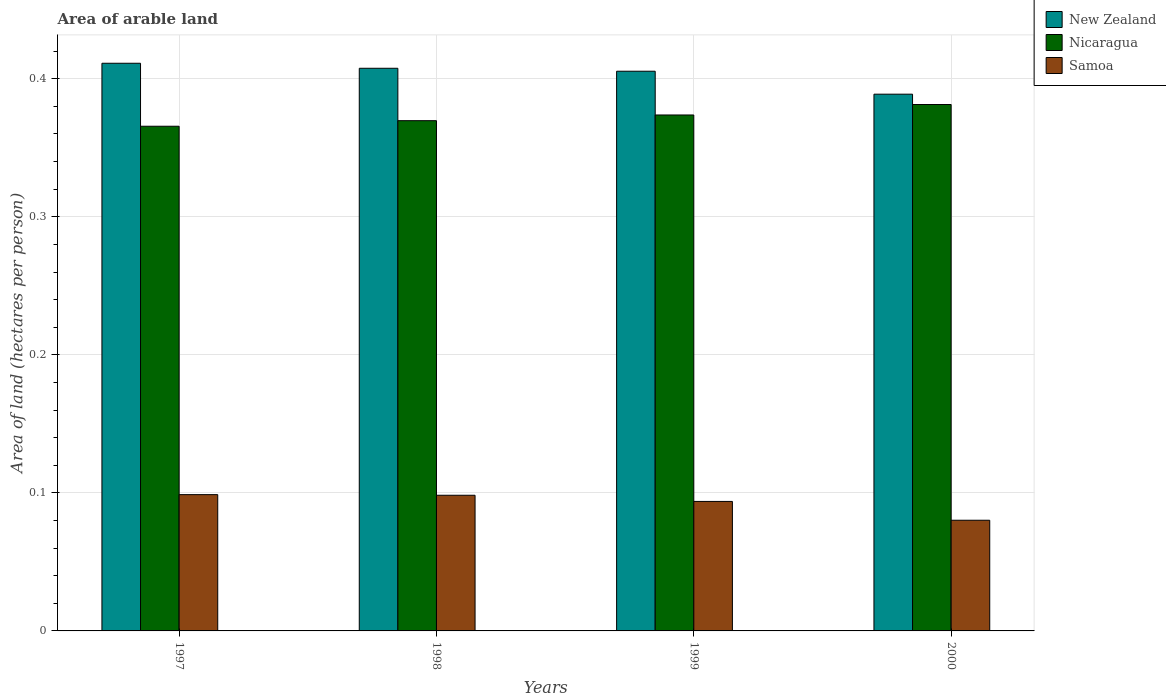How many different coloured bars are there?
Keep it short and to the point. 3. Are the number of bars per tick equal to the number of legend labels?
Make the answer very short. Yes. What is the total arable land in Nicaragua in 1998?
Give a very brief answer. 0.37. Across all years, what is the maximum total arable land in Nicaragua?
Your response must be concise. 0.38. Across all years, what is the minimum total arable land in Nicaragua?
Keep it short and to the point. 0.37. What is the total total arable land in New Zealand in the graph?
Your answer should be very brief. 1.61. What is the difference between the total arable land in New Zealand in 1997 and that in 2000?
Offer a terse response. 0.02. What is the difference between the total arable land in Samoa in 1997 and the total arable land in New Zealand in 1998?
Keep it short and to the point. -0.31. What is the average total arable land in New Zealand per year?
Make the answer very short. 0.4. In the year 1998, what is the difference between the total arable land in Samoa and total arable land in Nicaragua?
Offer a terse response. -0.27. In how many years, is the total arable land in Samoa greater than 0.06 hectares per person?
Your answer should be very brief. 4. What is the ratio of the total arable land in New Zealand in 1997 to that in 1999?
Offer a terse response. 1.01. Is the total arable land in Samoa in 1997 less than that in 1999?
Your answer should be compact. No. Is the difference between the total arable land in Samoa in 1997 and 1999 greater than the difference between the total arable land in Nicaragua in 1997 and 1999?
Make the answer very short. Yes. What is the difference between the highest and the second highest total arable land in Samoa?
Your response must be concise. 0. What is the difference between the highest and the lowest total arable land in Samoa?
Your answer should be very brief. 0.02. In how many years, is the total arable land in New Zealand greater than the average total arable land in New Zealand taken over all years?
Offer a terse response. 3. What does the 3rd bar from the left in 1998 represents?
Your answer should be compact. Samoa. What does the 1st bar from the right in 1999 represents?
Provide a succinct answer. Samoa. How many bars are there?
Provide a short and direct response. 12. How many years are there in the graph?
Give a very brief answer. 4. What is the difference between two consecutive major ticks on the Y-axis?
Your response must be concise. 0.1. Does the graph contain any zero values?
Make the answer very short. No. Does the graph contain grids?
Provide a succinct answer. Yes. Where does the legend appear in the graph?
Provide a succinct answer. Top right. What is the title of the graph?
Offer a terse response. Area of arable land. What is the label or title of the X-axis?
Keep it short and to the point. Years. What is the label or title of the Y-axis?
Give a very brief answer. Area of land (hectares per person). What is the Area of land (hectares per person) of New Zealand in 1997?
Your answer should be very brief. 0.41. What is the Area of land (hectares per person) of Nicaragua in 1997?
Make the answer very short. 0.37. What is the Area of land (hectares per person) of Samoa in 1997?
Your response must be concise. 0.1. What is the Area of land (hectares per person) of New Zealand in 1998?
Your answer should be compact. 0.41. What is the Area of land (hectares per person) in Nicaragua in 1998?
Your response must be concise. 0.37. What is the Area of land (hectares per person) in Samoa in 1998?
Offer a very short reply. 0.1. What is the Area of land (hectares per person) of New Zealand in 1999?
Your answer should be very brief. 0.41. What is the Area of land (hectares per person) of Nicaragua in 1999?
Ensure brevity in your answer.  0.37. What is the Area of land (hectares per person) of Samoa in 1999?
Keep it short and to the point. 0.09. What is the Area of land (hectares per person) of New Zealand in 2000?
Offer a very short reply. 0.39. What is the Area of land (hectares per person) of Nicaragua in 2000?
Make the answer very short. 0.38. What is the Area of land (hectares per person) of Samoa in 2000?
Ensure brevity in your answer.  0.08. Across all years, what is the maximum Area of land (hectares per person) of New Zealand?
Offer a very short reply. 0.41. Across all years, what is the maximum Area of land (hectares per person) of Nicaragua?
Provide a short and direct response. 0.38. Across all years, what is the maximum Area of land (hectares per person) in Samoa?
Ensure brevity in your answer.  0.1. Across all years, what is the minimum Area of land (hectares per person) in New Zealand?
Give a very brief answer. 0.39. Across all years, what is the minimum Area of land (hectares per person) of Nicaragua?
Provide a succinct answer. 0.37. Across all years, what is the minimum Area of land (hectares per person) of Samoa?
Offer a very short reply. 0.08. What is the total Area of land (hectares per person) of New Zealand in the graph?
Make the answer very short. 1.61. What is the total Area of land (hectares per person) in Nicaragua in the graph?
Give a very brief answer. 1.49. What is the total Area of land (hectares per person) of Samoa in the graph?
Offer a very short reply. 0.37. What is the difference between the Area of land (hectares per person) of New Zealand in 1997 and that in 1998?
Your response must be concise. 0. What is the difference between the Area of land (hectares per person) of Nicaragua in 1997 and that in 1998?
Offer a very short reply. -0. What is the difference between the Area of land (hectares per person) of New Zealand in 1997 and that in 1999?
Keep it short and to the point. 0.01. What is the difference between the Area of land (hectares per person) in Nicaragua in 1997 and that in 1999?
Your answer should be very brief. -0.01. What is the difference between the Area of land (hectares per person) in Samoa in 1997 and that in 1999?
Offer a terse response. 0. What is the difference between the Area of land (hectares per person) of New Zealand in 1997 and that in 2000?
Keep it short and to the point. 0.02. What is the difference between the Area of land (hectares per person) of Nicaragua in 1997 and that in 2000?
Your answer should be compact. -0.02. What is the difference between the Area of land (hectares per person) in Samoa in 1997 and that in 2000?
Offer a terse response. 0.02. What is the difference between the Area of land (hectares per person) of New Zealand in 1998 and that in 1999?
Offer a terse response. 0. What is the difference between the Area of land (hectares per person) in Nicaragua in 1998 and that in 1999?
Offer a terse response. -0. What is the difference between the Area of land (hectares per person) of Samoa in 1998 and that in 1999?
Provide a short and direct response. 0. What is the difference between the Area of land (hectares per person) of New Zealand in 1998 and that in 2000?
Provide a short and direct response. 0.02. What is the difference between the Area of land (hectares per person) of Nicaragua in 1998 and that in 2000?
Your answer should be compact. -0.01. What is the difference between the Area of land (hectares per person) of Samoa in 1998 and that in 2000?
Your answer should be compact. 0.02. What is the difference between the Area of land (hectares per person) of New Zealand in 1999 and that in 2000?
Offer a terse response. 0.02. What is the difference between the Area of land (hectares per person) in Nicaragua in 1999 and that in 2000?
Give a very brief answer. -0.01. What is the difference between the Area of land (hectares per person) of Samoa in 1999 and that in 2000?
Make the answer very short. 0.01. What is the difference between the Area of land (hectares per person) in New Zealand in 1997 and the Area of land (hectares per person) in Nicaragua in 1998?
Provide a succinct answer. 0.04. What is the difference between the Area of land (hectares per person) in New Zealand in 1997 and the Area of land (hectares per person) in Samoa in 1998?
Make the answer very short. 0.31. What is the difference between the Area of land (hectares per person) in Nicaragua in 1997 and the Area of land (hectares per person) in Samoa in 1998?
Provide a short and direct response. 0.27. What is the difference between the Area of land (hectares per person) in New Zealand in 1997 and the Area of land (hectares per person) in Nicaragua in 1999?
Keep it short and to the point. 0.04. What is the difference between the Area of land (hectares per person) of New Zealand in 1997 and the Area of land (hectares per person) of Samoa in 1999?
Make the answer very short. 0.32. What is the difference between the Area of land (hectares per person) of Nicaragua in 1997 and the Area of land (hectares per person) of Samoa in 1999?
Your answer should be very brief. 0.27. What is the difference between the Area of land (hectares per person) of New Zealand in 1997 and the Area of land (hectares per person) of Nicaragua in 2000?
Provide a succinct answer. 0.03. What is the difference between the Area of land (hectares per person) in New Zealand in 1997 and the Area of land (hectares per person) in Samoa in 2000?
Ensure brevity in your answer.  0.33. What is the difference between the Area of land (hectares per person) of Nicaragua in 1997 and the Area of land (hectares per person) of Samoa in 2000?
Your response must be concise. 0.29. What is the difference between the Area of land (hectares per person) in New Zealand in 1998 and the Area of land (hectares per person) in Nicaragua in 1999?
Your answer should be very brief. 0.03. What is the difference between the Area of land (hectares per person) of New Zealand in 1998 and the Area of land (hectares per person) of Samoa in 1999?
Your response must be concise. 0.31. What is the difference between the Area of land (hectares per person) of Nicaragua in 1998 and the Area of land (hectares per person) of Samoa in 1999?
Ensure brevity in your answer.  0.28. What is the difference between the Area of land (hectares per person) of New Zealand in 1998 and the Area of land (hectares per person) of Nicaragua in 2000?
Give a very brief answer. 0.03. What is the difference between the Area of land (hectares per person) of New Zealand in 1998 and the Area of land (hectares per person) of Samoa in 2000?
Offer a very short reply. 0.33. What is the difference between the Area of land (hectares per person) of Nicaragua in 1998 and the Area of land (hectares per person) of Samoa in 2000?
Offer a very short reply. 0.29. What is the difference between the Area of land (hectares per person) of New Zealand in 1999 and the Area of land (hectares per person) of Nicaragua in 2000?
Provide a succinct answer. 0.02. What is the difference between the Area of land (hectares per person) of New Zealand in 1999 and the Area of land (hectares per person) of Samoa in 2000?
Your answer should be very brief. 0.33. What is the difference between the Area of land (hectares per person) of Nicaragua in 1999 and the Area of land (hectares per person) of Samoa in 2000?
Offer a terse response. 0.29. What is the average Area of land (hectares per person) of New Zealand per year?
Make the answer very short. 0.4. What is the average Area of land (hectares per person) of Nicaragua per year?
Your response must be concise. 0.37. What is the average Area of land (hectares per person) in Samoa per year?
Ensure brevity in your answer.  0.09. In the year 1997, what is the difference between the Area of land (hectares per person) in New Zealand and Area of land (hectares per person) in Nicaragua?
Keep it short and to the point. 0.05. In the year 1997, what is the difference between the Area of land (hectares per person) in New Zealand and Area of land (hectares per person) in Samoa?
Your answer should be compact. 0.31. In the year 1997, what is the difference between the Area of land (hectares per person) in Nicaragua and Area of land (hectares per person) in Samoa?
Offer a very short reply. 0.27. In the year 1998, what is the difference between the Area of land (hectares per person) of New Zealand and Area of land (hectares per person) of Nicaragua?
Provide a succinct answer. 0.04. In the year 1998, what is the difference between the Area of land (hectares per person) of New Zealand and Area of land (hectares per person) of Samoa?
Keep it short and to the point. 0.31. In the year 1998, what is the difference between the Area of land (hectares per person) of Nicaragua and Area of land (hectares per person) of Samoa?
Keep it short and to the point. 0.27. In the year 1999, what is the difference between the Area of land (hectares per person) of New Zealand and Area of land (hectares per person) of Nicaragua?
Offer a very short reply. 0.03. In the year 1999, what is the difference between the Area of land (hectares per person) in New Zealand and Area of land (hectares per person) in Samoa?
Offer a very short reply. 0.31. In the year 1999, what is the difference between the Area of land (hectares per person) in Nicaragua and Area of land (hectares per person) in Samoa?
Give a very brief answer. 0.28. In the year 2000, what is the difference between the Area of land (hectares per person) in New Zealand and Area of land (hectares per person) in Nicaragua?
Give a very brief answer. 0.01. In the year 2000, what is the difference between the Area of land (hectares per person) of New Zealand and Area of land (hectares per person) of Samoa?
Provide a succinct answer. 0.31. In the year 2000, what is the difference between the Area of land (hectares per person) of Nicaragua and Area of land (hectares per person) of Samoa?
Make the answer very short. 0.3. What is the ratio of the Area of land (hectares per person) of New Zealand in 1997 to that in 1998?
Your response must be concise. 1.01. What is the ratio of the Area of land (hectares per person) of New Zealand in 1997 to that in 1999?
Offer a very short reply. 1.01. What is the ratio of the Area of land (hectares per person) of Nicaragua in 1997 to that in 1999?
Offer a terse response. 0.98. What is the ratio of the Area of land (hectares per person) of Samoa in 1997 to that in 1999?
Your response must be concise. 1.05. What is the ratio of the Area of land (hectares per person) in New Zealand in 1997 to that in 2000?
Offer a very short reply. 1.06. What is the ratio of the Area of land (hectares per person) of Nicaragua in 1997 to that in 2000?
Make the answer very short. 0.96. What is the ratio of the Area of land (hectares per person) in Samoa in 1997 to that in 2000?
Ensure brevity in your answer.  1.23. What is the ratio of the Area of land (hectares per person) of Samoa in 1998 to that in 1999?
Keep it short and to the point. 1.05. What is the ratio of the Area of land (hectares per person) in New Zealand in 1998 to that in 2000?
Your answer should be compact. 1.05. What is the ratio of the Area of land (hectares per person) of Nicaragua in 1998 to that in 2000?
Offer a terse response. 0.97. What is the ratio of the Area of land (hectares per person) of Samoa in 1998 to that in 2000?
Make the answer very short. 1.23. What is the ratio of the Area of land (hectares per person) of New Zealand in 1999 to that in 2000?
Offer a very short reply. 1.04. What is the ratio of the Area of land (hectares per person) in Nicaragua in 1999 to that in 2000?
Give a very brief answer. 0.98. What is the ratio of the Area of land (hectares per person) of Samoa in 1999 to that in 2000?
Give a very brief answer. 1.17. What is the difference between the highest and the second highest Area of land (hectares per person) in New Zealand?
Offer a terse response. 0. What is the difference between the highest and the second highest Area of land (hectares per person) in Nicaragua?
Your answer should be compact. 0.01. What is the difference between the highest and the second highest Area of land (hectares per person) of Samoa?
Your response must be concise. 0. What is the difference between the highest and the lowest Area of land (hectares per person) in New Zealand?
Give a very brief answer. 0.02. What is the difference between the highest and the lowest Area of land (hectares per person) of Nicaragua?
Give a very brief answer. 0.02. What is the difference between the highest and the lowest Area of land (hectares per person) of Samoa?
Make the answer very short. 0.02. 